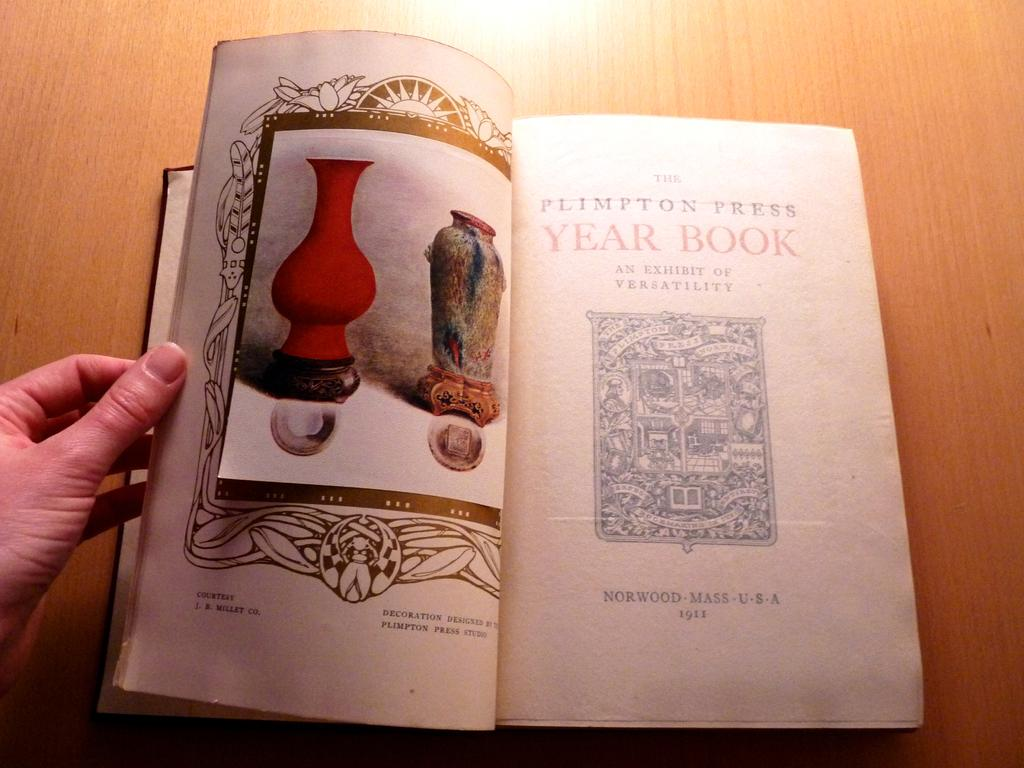Provide a one-sentence caption for the provided image. A hand holds the Plimpton Press Year Book open to its title page. 